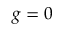<formula> <loc_0><loc_0><loc_500><loc_500>g = 0</formula> 